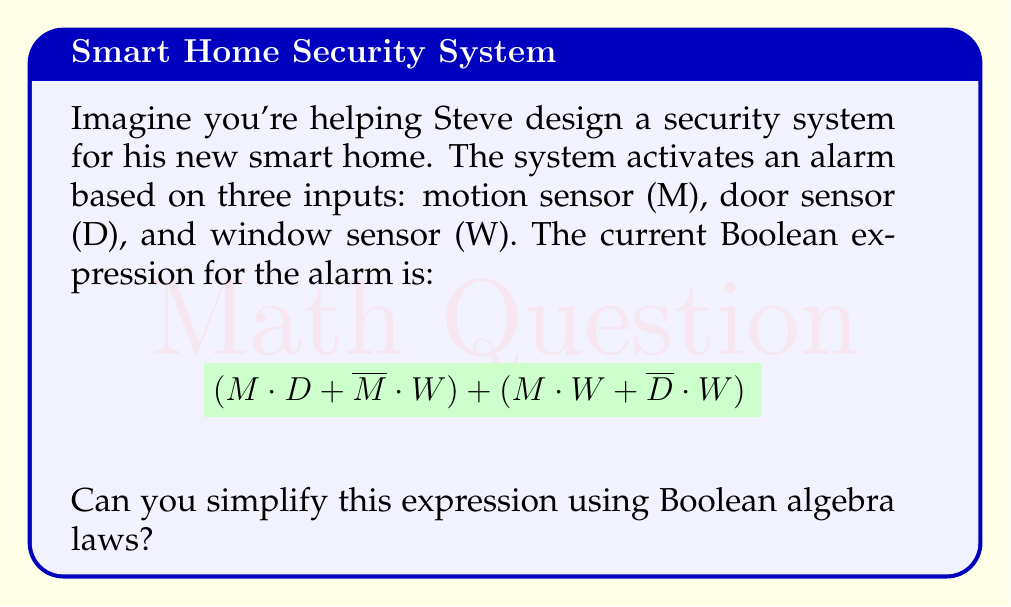Help me with this question. Let's simplify the expression step by step:

1) First, let's distribute $M$ over $(D + W)$ in the first term:
   $$(M \cdot D + M \cdot W + \overline{M} \cdot W) + (\overline{D} \cdot W)$$

2) Now, we can use the associative law to rearrange the terms:
   $$(M \cdot D) + (M \cdot W) + (\overline{M} \cdot W) + (\overline{D} \cdot W)$$

3) We can factor out $W$ from the last two terms:
   $$(M \cdot D) + (M \cdot W) + W \cdot (\overline{M} + \overline{D})$$

4) Using De Morgan's law, $\overline{M} + \overline{D} = \overline{M \cdot D}$:
   $$(M \cdot D) + (M \cdot W) + W \cdot \overline{(M \cdot D)}$$

5) Now we can use the absorption law: $X + Y \cdot \overline{X} = X + Y$
   Let $X = M \cdot D$ and $Y = W$:
   $$(M \cdot D) + W$$

This is our simplified expression.
Answer: $M \cdot D + W$ 